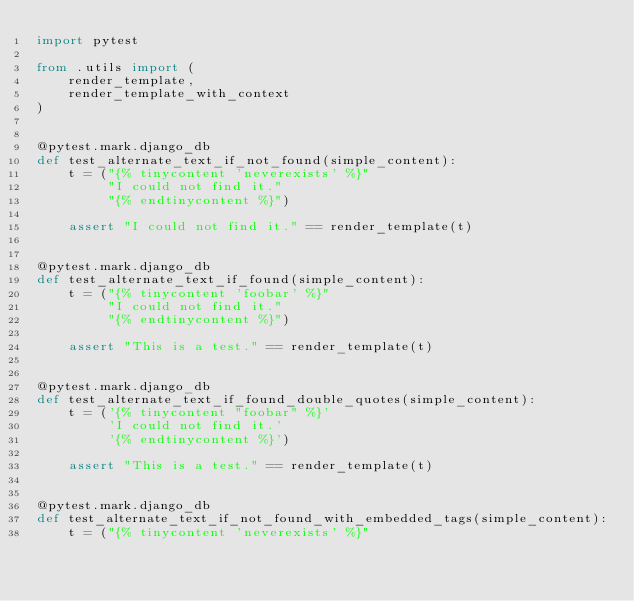<code> <loc_0><loc_0><loc_500><loc_500><_Python_>import pytest

from .utils import (
    render_template,
    render_template_with_context
)


@pytest.mark.django_db
def test_alternate_text_if_not_found(simple_content):
    t = ("{% tinycontent 'neverexists' %}"
         "I could not find it."
         "{% endtinycontent %}")

    assert "I could not find it." == render_template(t)


@pytest.mark.django_db
def test_alternate_text_if_found(simple_content):
    t = ("{% tinycontent 'foobar' %}"
         "I could not find it."
         "{% endtinycontent %}")

    assert "This is a test." == render_template(t)


@pytest.mark.django_db
def test_alternate_text_if_found_double_quotes(simple_content):
    t = ('{% tinycontent "foobar" %}'
         'I could not find it.'
         '{% endtinycontent %}')

    assert "This is a test." == render_template(t)


@pytest.mark.django_db
def test_alternate_text_if_not_found_with_embedded_tags(simple_content):
    t = ("{% tinycontent 'neverexists' %}"</code> 